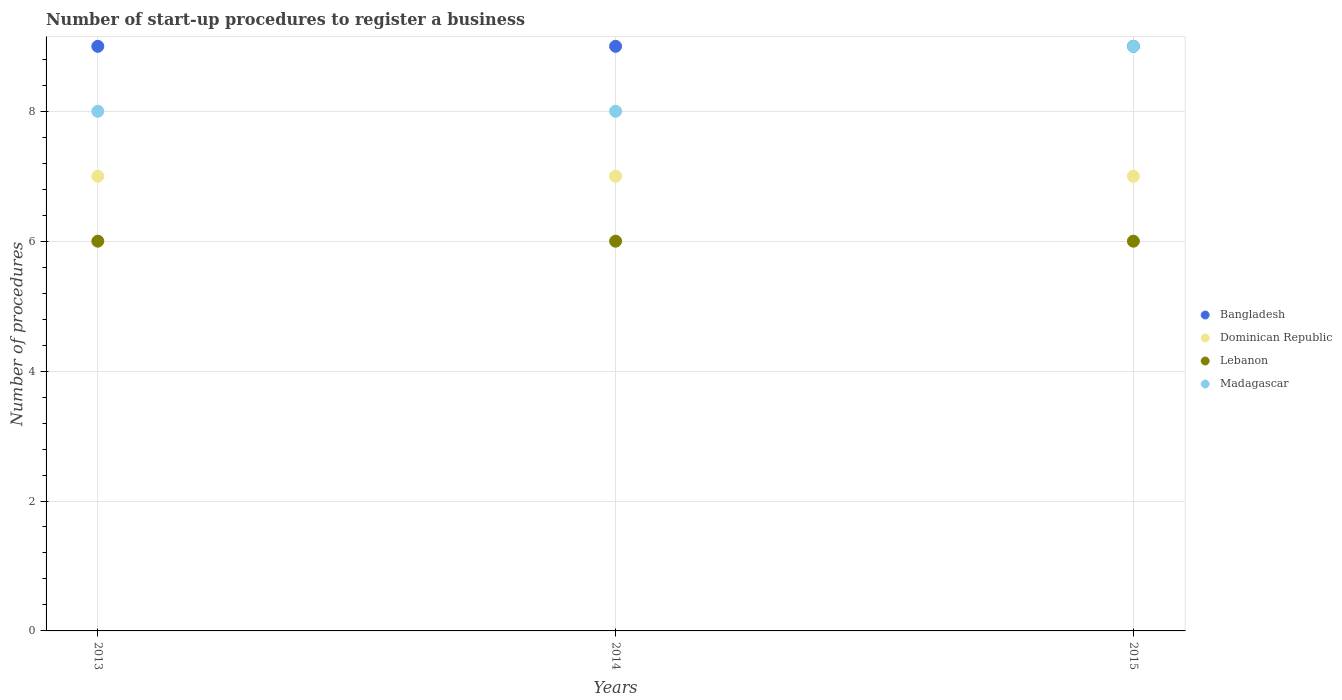Is the number of dotlines equal to the number of legend labels?
Provide a succinct answer. Yes. What is the number of procedures required to register a business in Bangladesh in 2014?
Offer a very short reply. 9. Across all years, what is the maximum number of procedures required to register a business in Dominican Republic?
Give a very brief answer. 7. In which year was the number of procedures required to register a business in Madagascar maximum?
Make the answer very short. 2015. In which year was the number of procedures required to register a business in Lebanon minimum?
Provide a short and direct response. 2013. What is the total number of procedures required to register a business in Lebanon in the graph?
Ensure brevity in your answer.  18. What is the difference between the number of procedures required to register a business in Bangladesh in 2013 and that in 2014?
Provide a succinct answer. 0. What is the difference between the number of procedures required to register a business in Dominican Republic in 2013 and the number of procedures required to register a business in Bangladesh in 2014?
Provide a short and direct response. -2. What is the average number of procedures required to register a business in Bangladesh per year?
Provide a succinct answer. 9. In how many years, is the number of procedures required to register a business in Bangladesh greater than 3.6?
Your answer should be very brief. 3. What is the difference between the highest and the second highest number of procedures required to register a business in Dominican Republic?
Make the answer very short. 0. Is the sum of the number of procedures required to register a business in Dominican Republic in 2014 and 2015 greater than the maximum number of procedures required to register a business in Lebanon across all years?
Your answer should be very brief. Yes. Is it the case that in every year, the sum of the number of procedures required to register a business in Dominican Republic and number of procedures required to register a business in Madagascar  is greater than the sum of number of procedures required to register a business in Bangladesh and number of procedures required to register a business in Lebanon?
Make the answer very short. No. Is it the case that in every year, the sum of the number of procedures required to register a business in Dominican Republic and number of procedures required to register a business in Bangladesh  is greater than the number of procedures required to register a business in Madagascar?
Keep it short and to the point. Yes. Does the graph contain any zero values?
Give a very brief answer. No. Does the graph contain grids?
Ensure brevity in your answer.  Yes. How many legend labels are there?
Provide a succinct answer. 4. How are the legend labels stacked?
Offer a terse response. Vertical. What is the title of the graph?
Ensure brevity in your answer.  Number of start-up procedures to register a business. What is the label or title of the X-axis?
Provide a succinct answer. Years. What is the label or title of the Y-axis?
Make the answer very short. Number of procedures. What is the Number of procedures in Bangladesh in 2013?
Provide a short and direct response. 9. What is the Number of procedures in Dominican Republic in 2014?
Offer a terse response. 7. What is the Number of procedures of Madagascar in 2015?
Provide a short and direct response. 9. Across all years, what is the maximum Number of procedures in Dominican Republic?
Your response must be concise. 7. Across all years, what is the minimum Number of procedures of Dominican Republic?
Your answer should be compact. 7. Across all years, what is the minimum Number of procedures of Lebanon?
Your answer should be compact. 6. Across all years, what is the minimum Number of procedures of Madagascar?
Your response must be concise. 8. What is the difference between the Number of procedures of Bangladesh in 2013 and that in 2014?
Give a very brief answer. 0. What is the difference between the Number of procedures in Dominican Republic in 2013 and that in 2014?
Make the answer very short. 0. What is the difference between the Number of procedures in Lebanon in 2013 and that in 2014?
Provide a short and direct response. 0. What is the difference between the Number of procedures in Dominican Republic in 2013 and that in 2015?
Offer a very short reply. 0. What is the difference between the Number of procedures of Lebanon in 2013 and that in 2015?
Offer a very short reply. 0. What is the difference between the Number of procedures of Madagascar in 2013 and that in 2015?
Your response must be concise. -1. What is the difference between the Number of procedures of Bangladesh in 2014 and that in 2015?
Provide a short and direct response. 0. What is the difference between the Number of procedures of Dominican Republic in 2014 and that in 2015?
Provide a succinct answer. 0. What is the difference between the Number of procedures of Madagascar in 2014 and that in 2015?
Make the answer very short. -1. What is the difference between the Number of procedures of Bangladesh in 2013 and the Number of procedures of Madagascar in 2014?
Give a very brief answer. 1. What is the difference between the Number of procedures in Dominican Republic in 2013 and the Number of procedures in Lebanon in 2014?
Ensure brevity in your answer.  1. What is the difference between the Number of procedures of Lebanon in 2013 and the Number of procedures of Madagascar in 2014?
Your answer should be compact. -2. What is the difference between the Number of procedures in Bangladesh in 2013 and the Number of procedures in Lebanon in 2015?
Your response must be concise. 3. What is the difference between the Number of procedures in Dominican Republic in 2013 and the Number of procedures in Madagascar in 2015?
Provide a succinct answer. -2. What is the difference between the Number of procedures of Bangladesh in 2014 and the Number of procedures of Dominican Republic in 2015?
Your answer should be compact. 2. What is the difference between the Number of procedures of Bangladesh in 2014 and the Number of procedures of Lebanon in 2015?
Your response must be concise. 3. What is the difference between the Number of procedures of Lebanon in 2014 and the Number of procedures of Madagascar in 2015?
Offer a terse response. -3. What is the average Number of procedures of Dominican Republic per year?
Your response must be concise. 7. What is the average Number of procedures in Lebanon per year?
Offer a terse response. 6. What is the average Number of procedures in Madagascar per year?
Ensure brevity in your answer.  8.33. In the year 2013, what is the difference between the Number of procedures of Bangladesh and Number of procedures of Lebanon?
Your answer should be compact. 3. In the year 2013, what is the difference between the Number of procedures in Dominican Republic and Number of procedures in Madagascar?
Keep it short and to the point. -1. In the year 2014, what is the difference between the Number of procedures in Bangladesh and Number of procedures in Lebanon?
Make the answer very short. 3. In the year 2014, what is the difference between the Number of procedures of Dominican Republic and Number of procedures of Lebanon?
Give a very brief answer. 1. In the year 2014, what is the difference between the Number of procedures in Lebanon and Number of procedures in Madagascar?
Offer a very short reply. -2. In the year 2015, what is the difference between the Number of procedures of Lebanon and Number of procedures of Madagascar?
Provide a succinct answer. -3. What is the ratio of the Number of procedures in Dominican Republic in 2013 to that in 2014?
Ensure brevity in your answer.  1. What is the ratio of the Number of procedures in Dominican Republic in 2013 to that in 2015?
Your answer should be very brief. 1. What is the ratio of the Number of procedures of Lebanon in 2013 to that in 2015?
Your answer should be very brief. 1. What is the ratio of the Number of procedures of Lebanon in 2014 to that in 2015?
Provide a short and direct response. 1. What is the ratio of the Number of procedures in Madagascar in 2014 to that in 2015?
Your answer should be compact. 0.89. What is the difference between the highest and the second highest Number of procedures of Bangladesh?
Your answer should be very brief. 0. What is the difference between the highest and the second highest Number of procedures in Dominican Republic?
Keep it short and to the point. 0. What is the difference between the highest and the second highest Number of procedures in Lebanon?
Provide a succinct answer. 0. What is the difference between the highest and the second highest Number of procedures in Madagascar?
Offer a very short reply. 1. What is the difference between the highest and the lowest Number of procedures in Bangladesh?
Your answer should be compact. 0. What is the difference between the highest and the lowest Number of procedures of Dominican Republic?
Provide a short and direct response. 0. What is the difference between the highest and the lowest Number of procedures of Lebanon?
Ensure brevity in your answer.  0. 